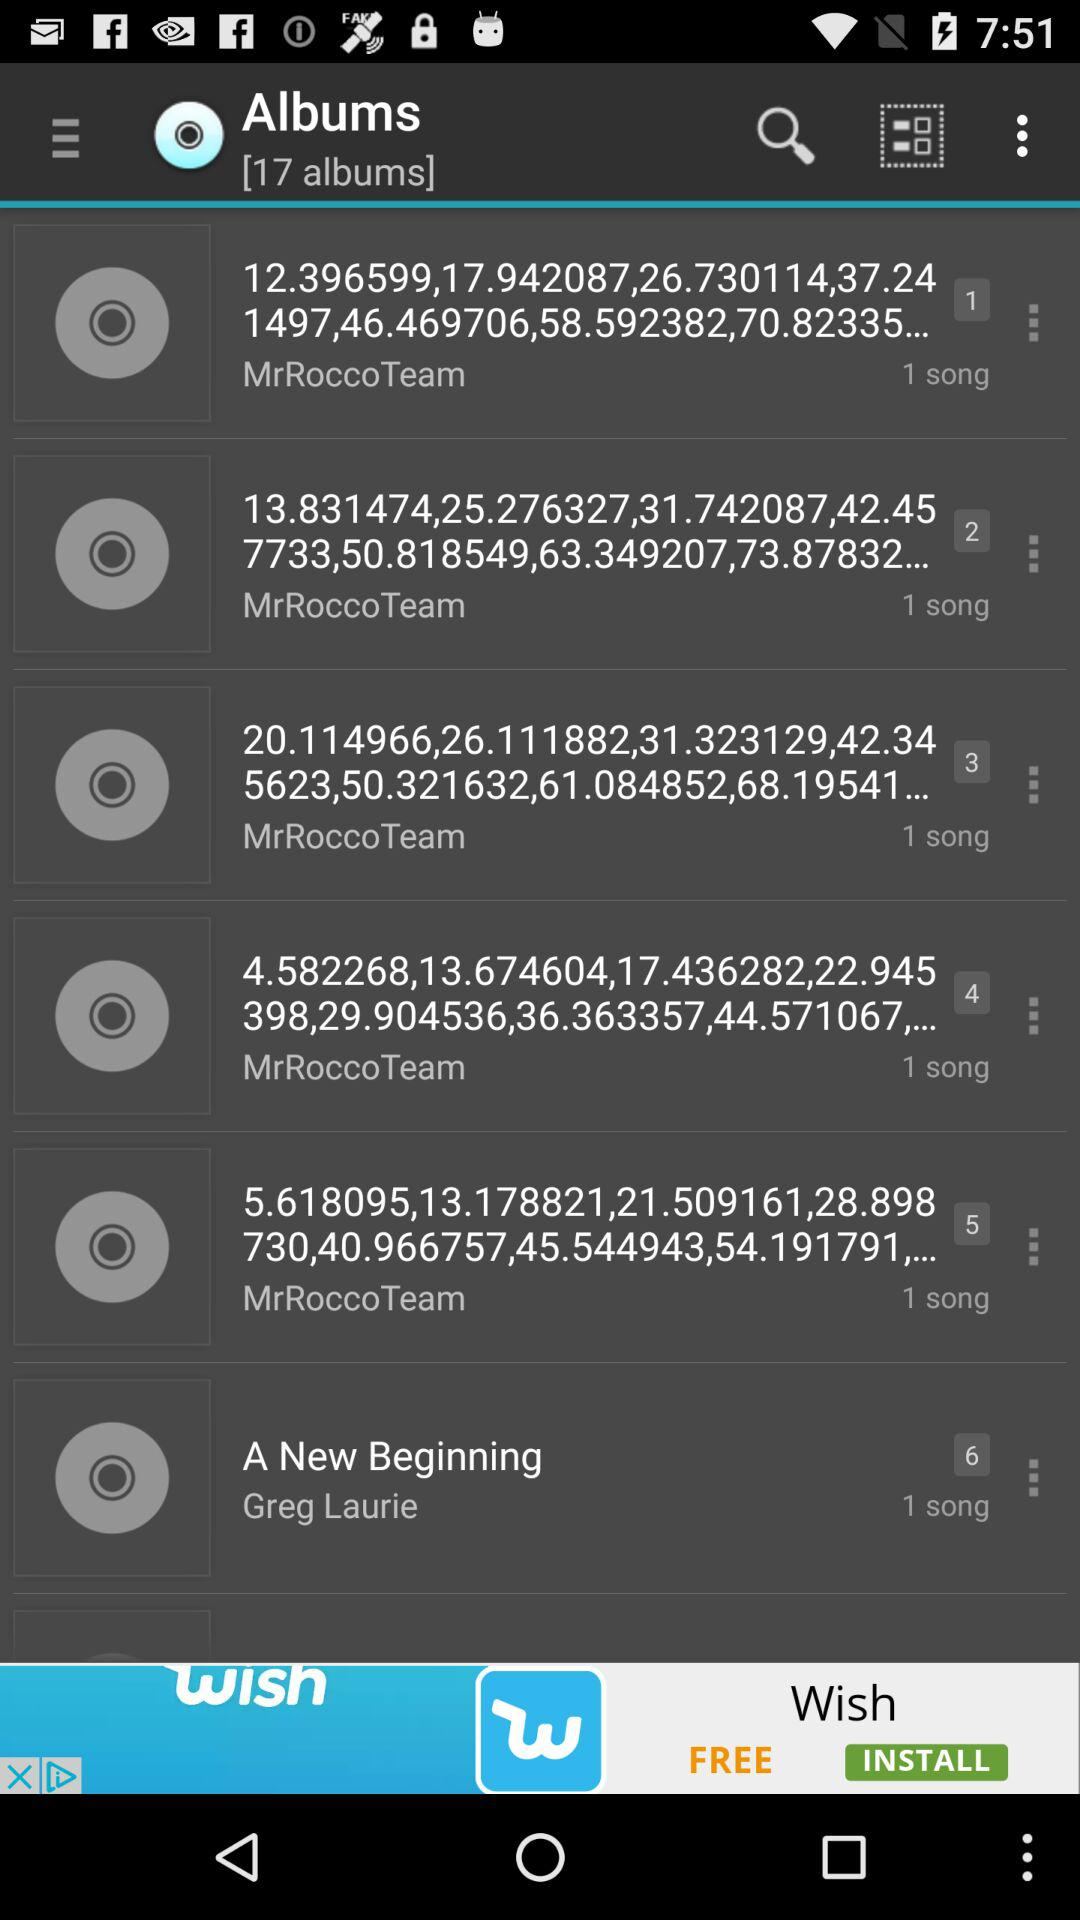How many songs are there in the album "A New Beginning"? There is 1 song in the album "A New Beginning". 